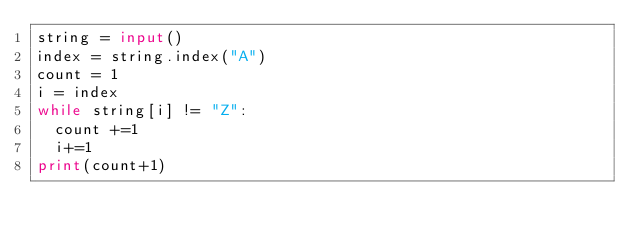<code> <loc_0><loc_0><loc_500><loc_500><_Python_>string = input()
index = string.index("A")
count = 1
i = index
while string[i] != "Z":
  count +=1
  i+=1
print(count+1)</code> 